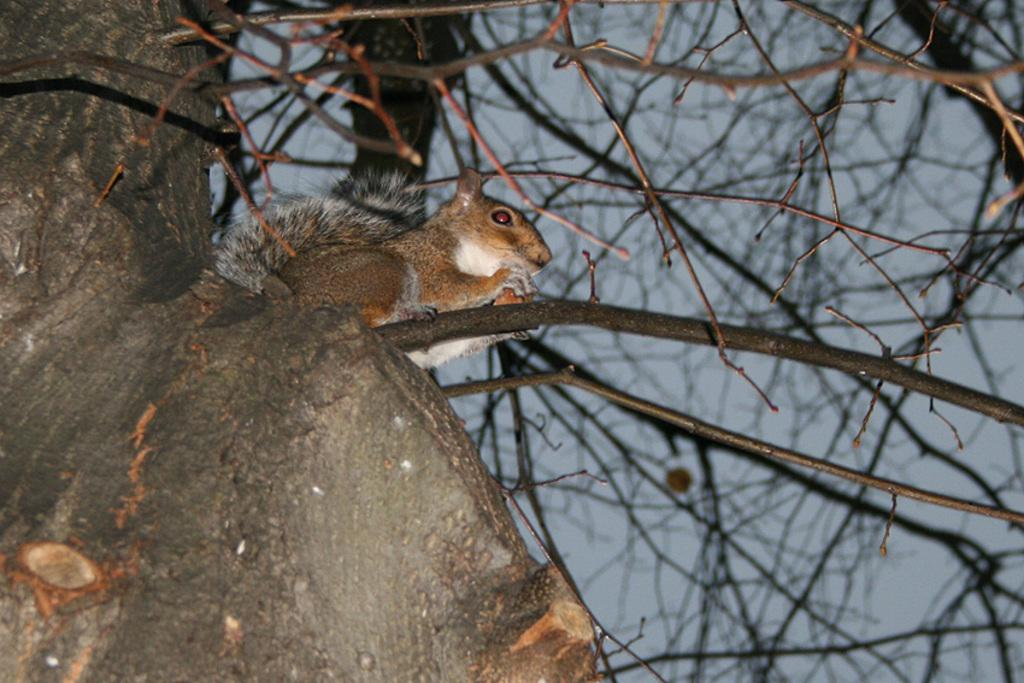What animal can be seen in the image? There is a squirrel in the image. What colors are present on the squirrel? The squirrel is brown, cream, and black in color. Where is the squirrel located in the image? The squirrel is on a tree. What can be seen in the background of the image? The sky is visible in the background of the image. What type of holiday is the squirrel celebrating in the image? There is no indication of a holiday in the image; it simply features a squirrel on a tree. Can you see any rocks in the image? There are no rocks visible in the image; it only shows a squirrel on a tree and the sky in the background. 